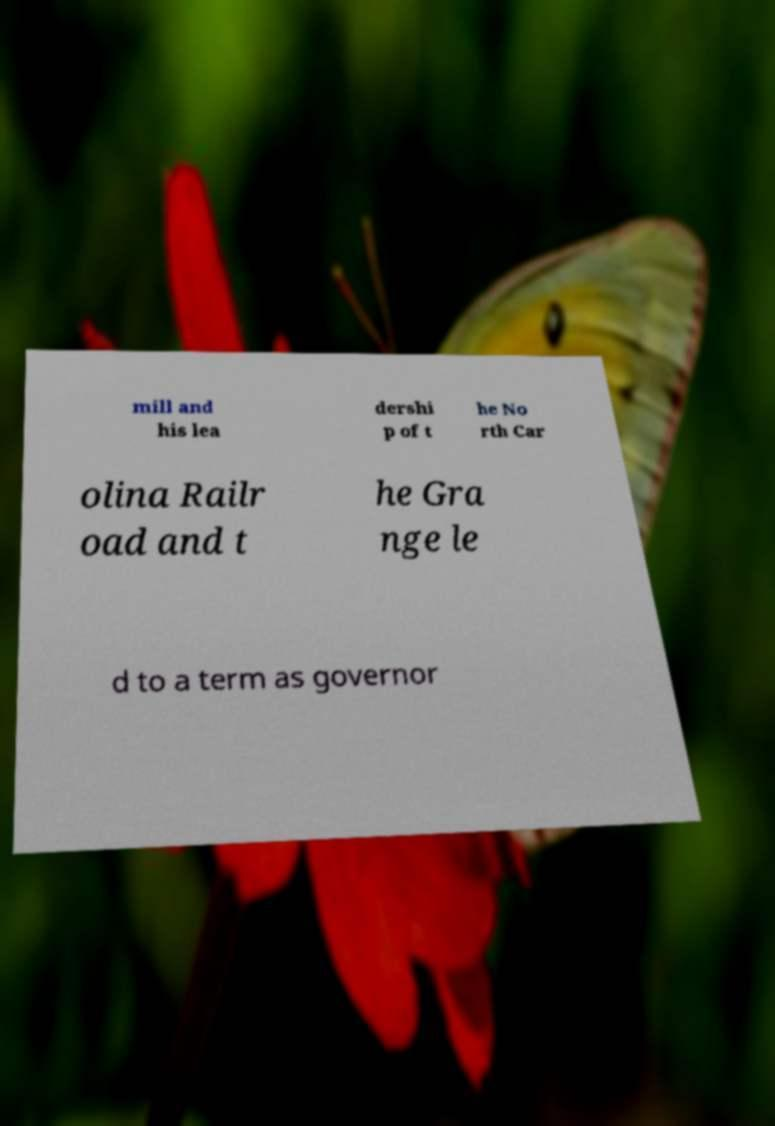For documentation purposes, I need the text within this image transcribed. Could you provide that? mill and his lea dershi p of t he No rth Car olina Railr oad and t he Gra nge le d to a term as governor 